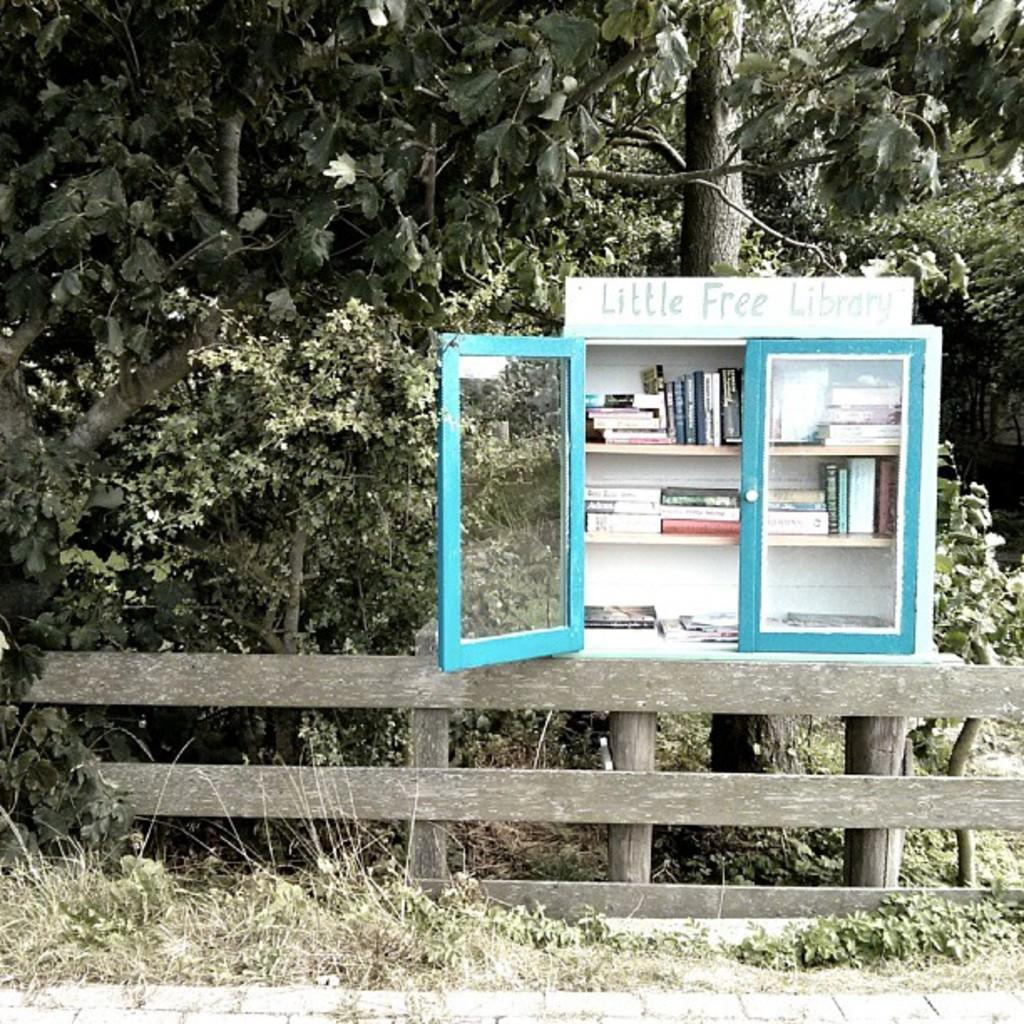<image>
Relay a brief, clear account of the picture shown. A Little Free Library case with books sits on the side of the road 